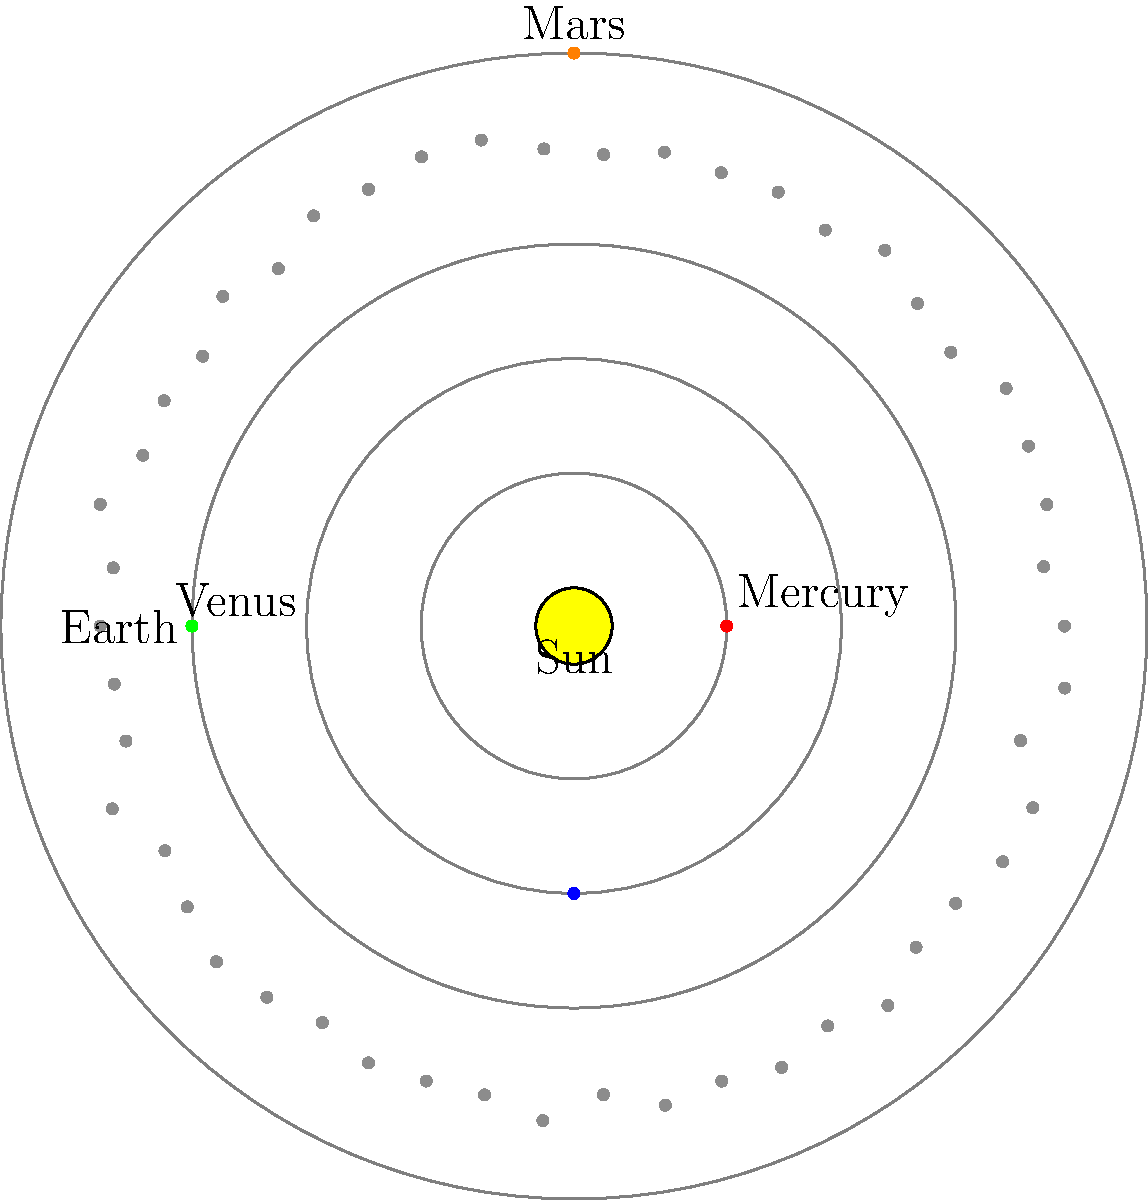In the context of privacy law and data protection, consider the structure of our solar system as a metaphor for information ecosystems. Which celestial body in this diagram represents the "core" of personal data, around which various privacy regulations and industry practices orbit, similar to how planets orbit the Sun? To answer this question, we need to analyze the diagram and draw parallels between the solar system and data privacy concepts:

1. The Sun is at the center of the solar system, just as personal data is at the core of privacy laws and regulations.

2. The planets (Mercury, Venus, Earth, and Mars) orbit the Sun at different distances, similar to how various privacy regulations and industry practices revolve around personal data protection.

3. The asteroid belt between Mars and the outer planets can be seen as the diverse array of emerging technologies and challenges in the privacy landscape.

4. In privacy law, personal data is the central element that everything else revolves around, just as the Sun is the central body in our solar system.

5. Different privacy regulations (like GDPR, CCPA, HIPAA) can be compared to the planets, each with its own "orbit" or scope of influence around personal data protection.

Given these parallels, the Sun in this diagram best represents the "core" of personal data in the privacy law context, as it is the central element around which everything else revolves.
Answer: The Sun 